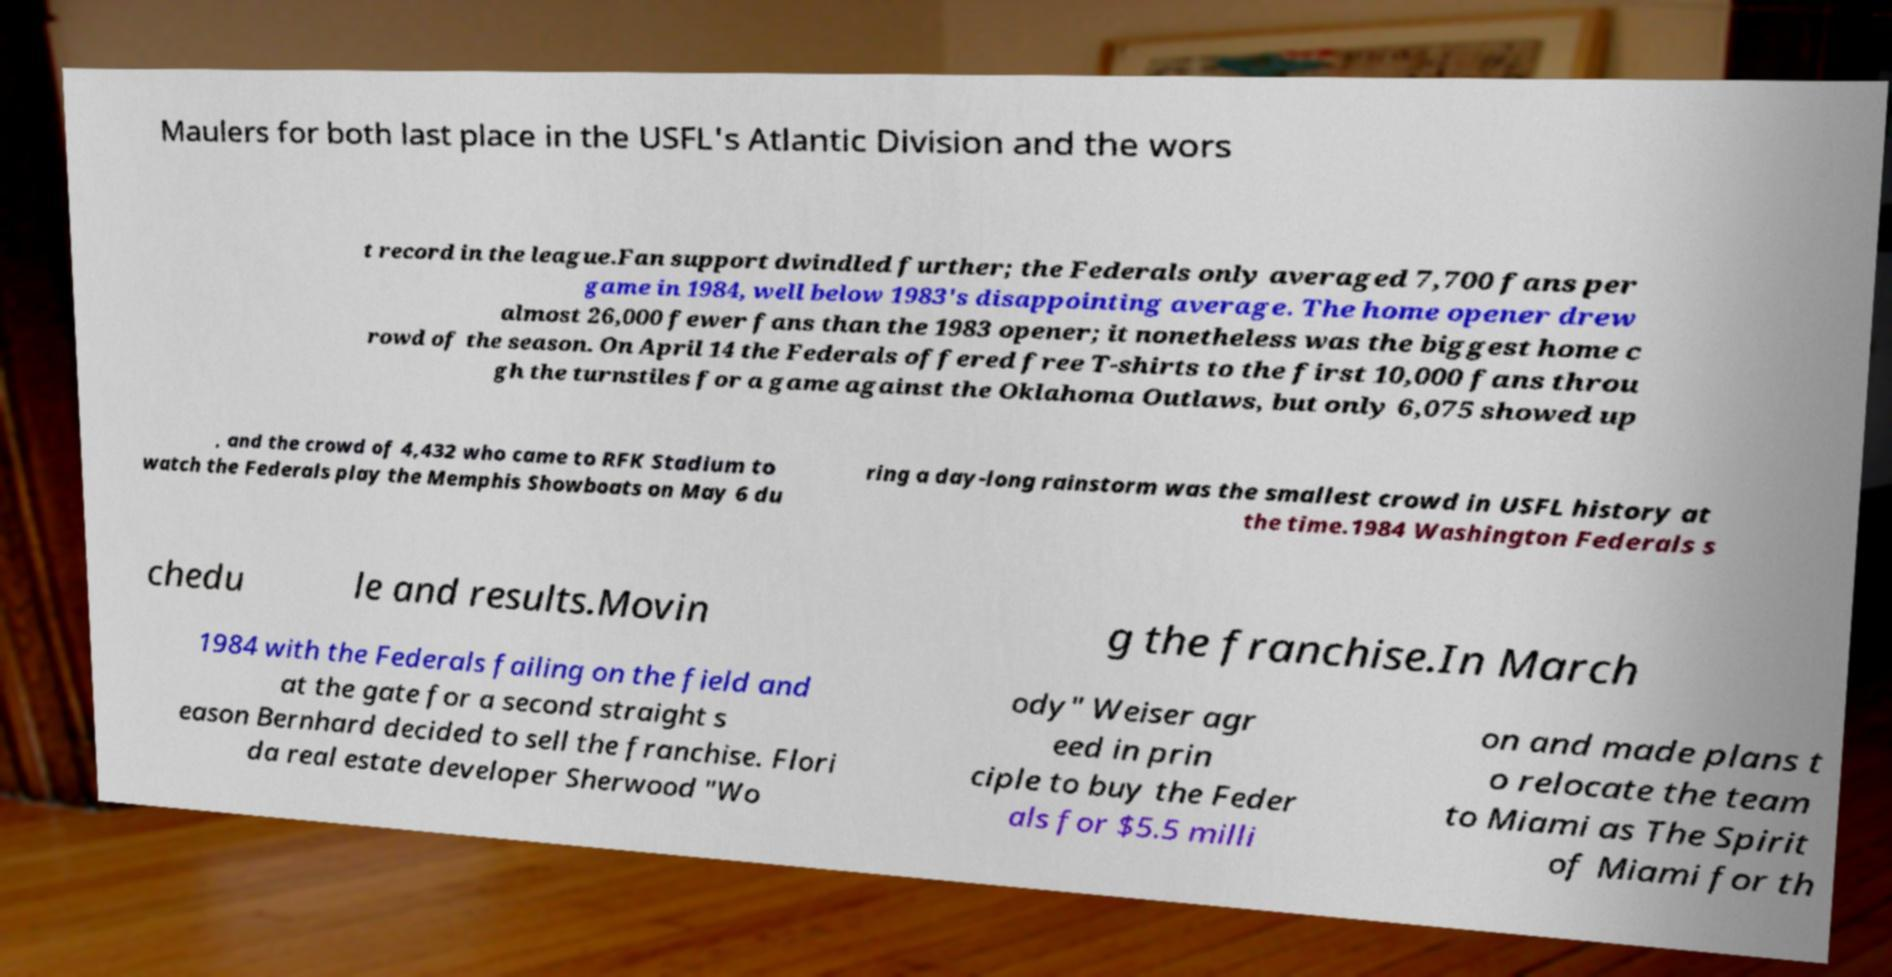I need the written content from this picture converted into text. Can you do that? Maulers for both last place in the USFL's Atlantic Division and the wors t record in the league.Fan support dwindled further; the Federals only averaged 7,700 fans per game in 1984, well below 1983's disappointing average. The home opener drew almost 26,000 fewer fans than the 1983 opener; it nonetheless was the biggest home c rowd of the season. On April 14 the Federals offered free T-shirts to the first 10,000 fans throu gh the turnstiles for a game against the Oklahoma Outlaws, but only 6,075 showed up , and the crowd of 4,432 who came to RFK Stadium to watch the Federals play the Memphis Showboats on May 6 du ring a day-long rainstorm was the smallest crowd in USFL history at the time.1984 Washington Federals s chedu le and results.Movin g the franchise.In March 1984 with the Federals failing on the field and at the gate for a second straight s eason Bernhard decided to sell the franchise. Flori da real estate developer Sherwood "Wo ody" Weiser agr eed in prin ciple to buy the Feder als for $5.5 milli on and made plans t o relocate the team to Miami as The Spirit of Miami for th 